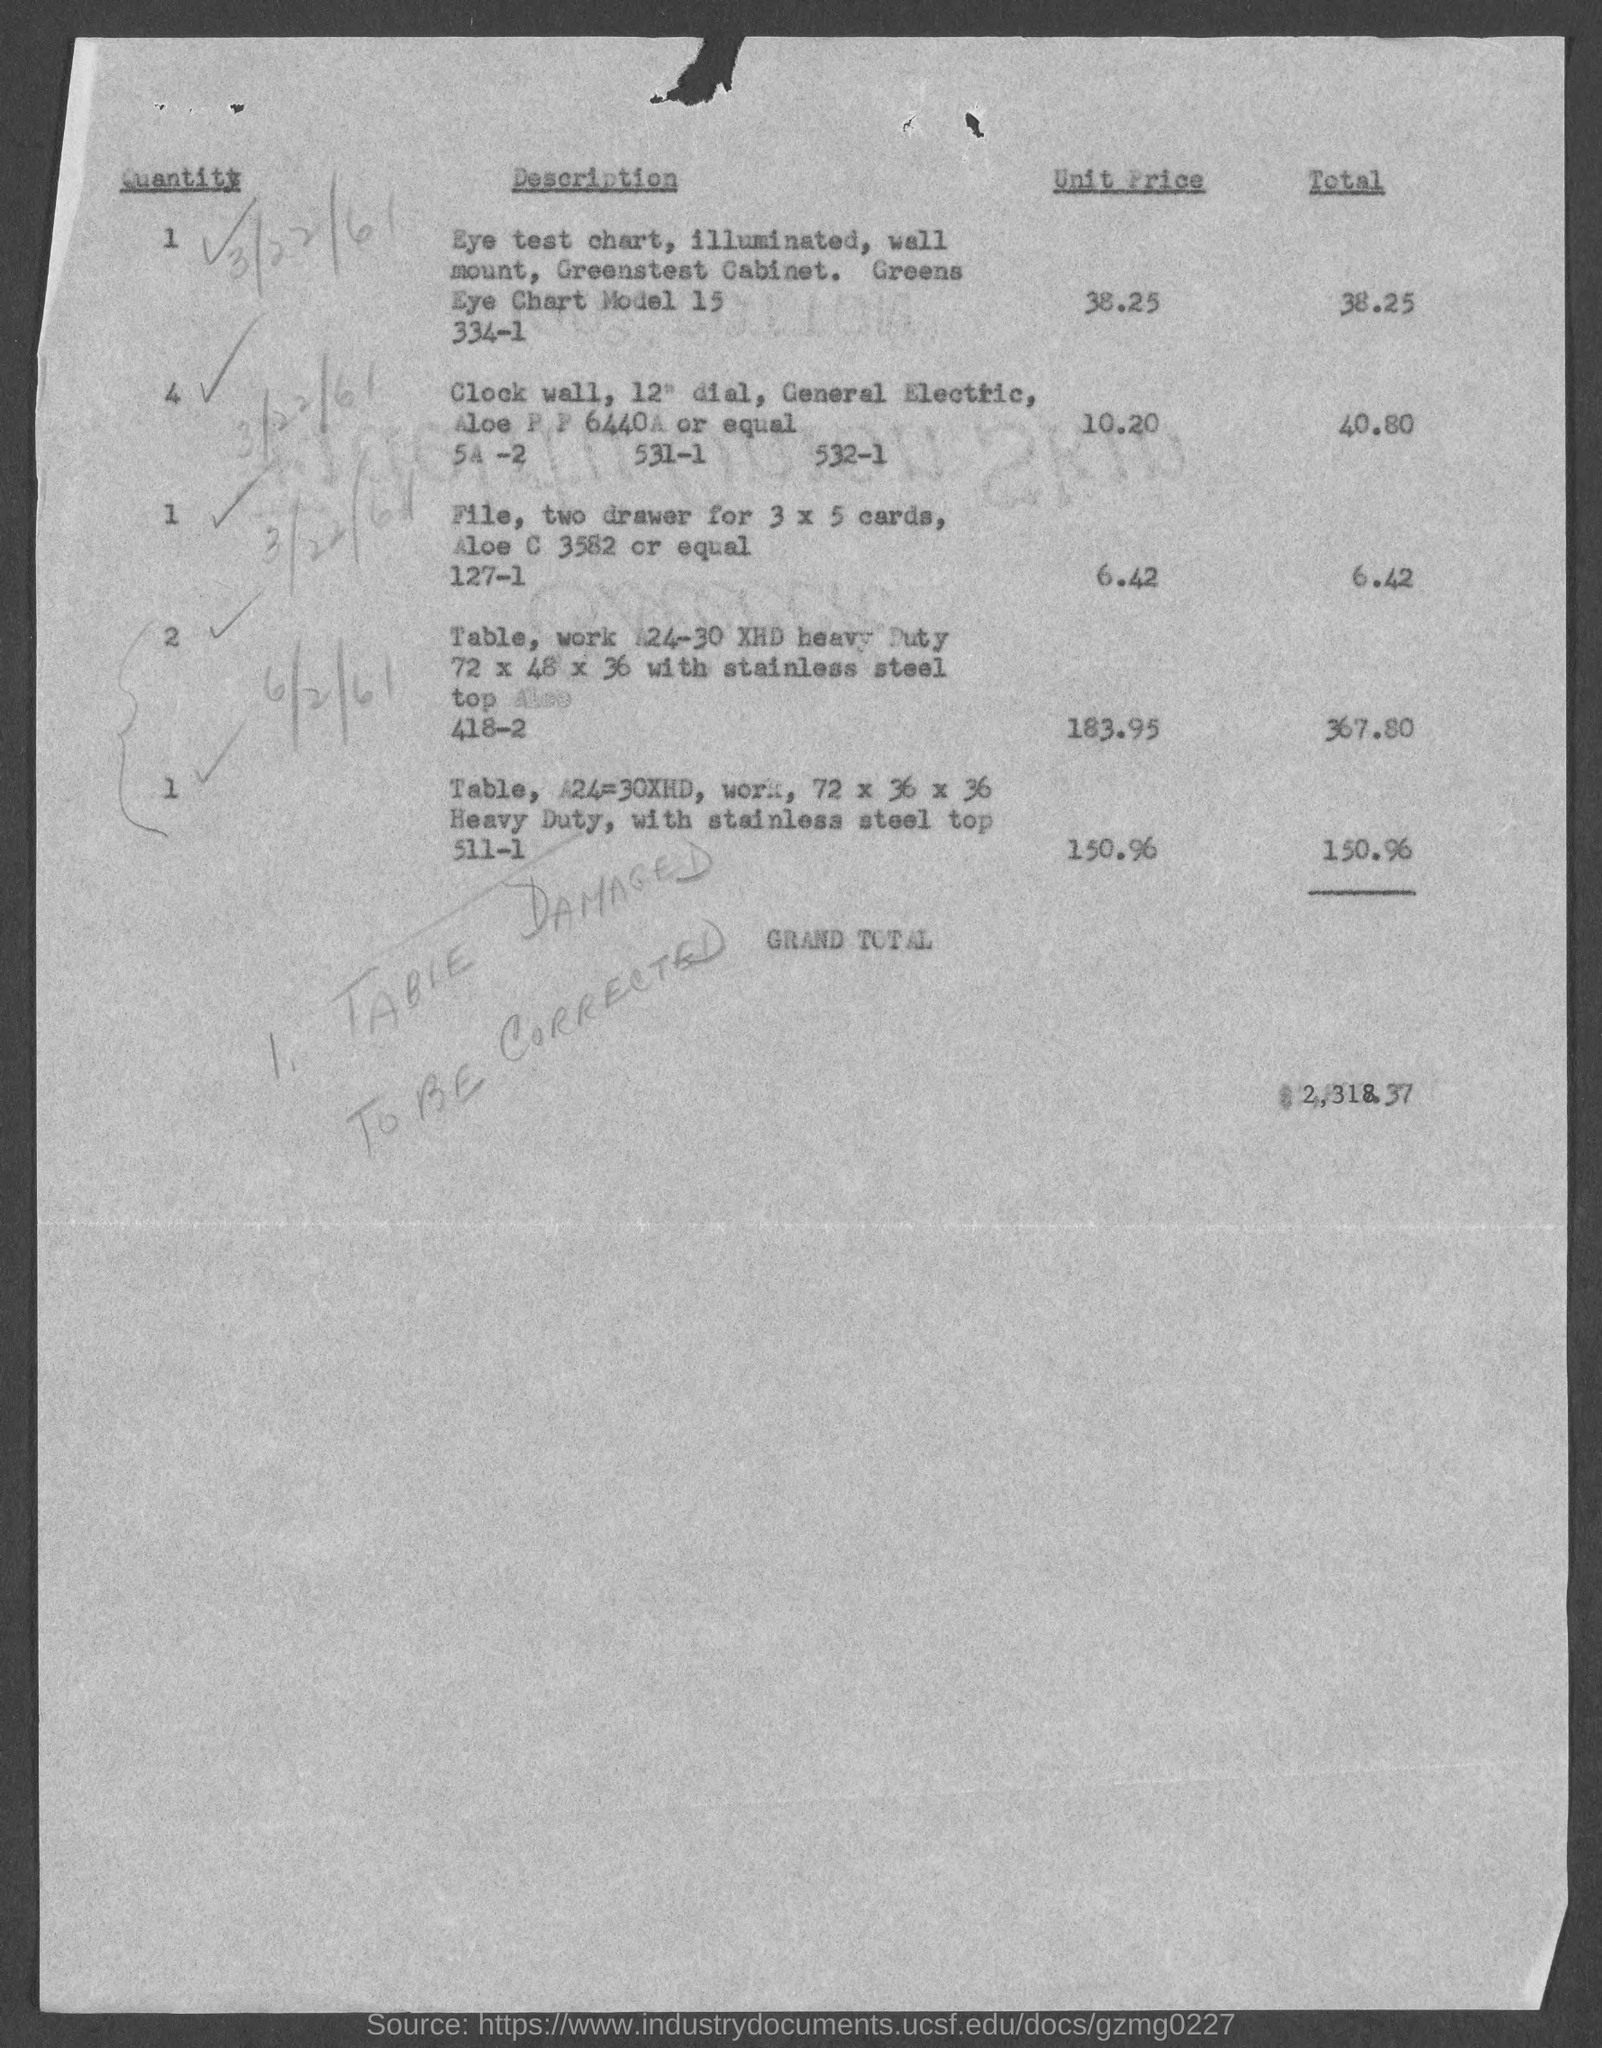Indicate a few pertinent items in this graphic. The unit price of the "Eye test chart" mentioned in the description is 38.25. The total value of the item "Clock wall" mentioned in the description is 40.80. The quantity of the item "Clock wall" mentioned in the description is 4.. 